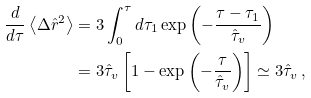<formula> <loc_0><loc_0><loc_500><loc_500>\frac { d } { d \tau } \left < \Delta \hat { r } ^ { 2 } \right > & = 3 \int _ { 0 } ^ { \tau } d \tau _ { 1 } \exp \left ( - \frac { \tau - \tau _ { 1 } } { \hat { \tau } _ { v } } \right ) \\ & = 3 \hat { \tau } _ { v } \left [ 1 - \exp \left ( - \frac { \tau } { \hat { \tau } _ { v } } \right ) \right ] \simeq 3 \hat { \tau } _ { v } \, ,</formula> 